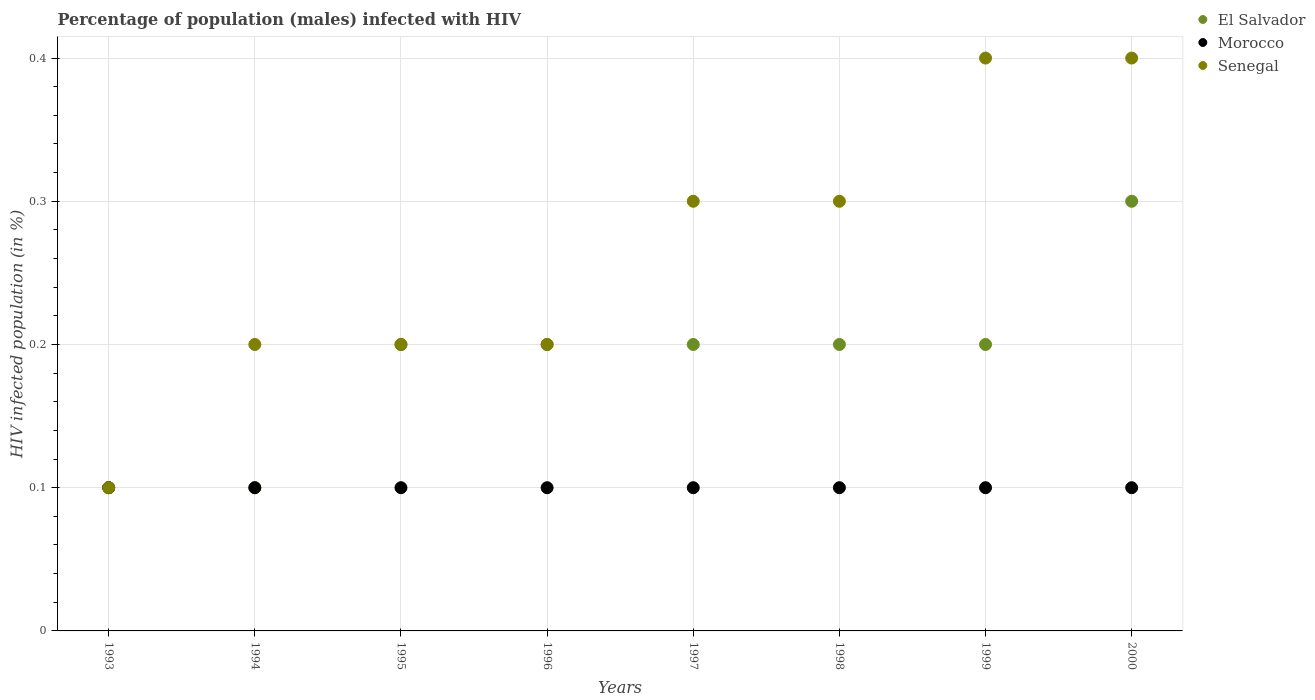Is the number of dotlines equal to the number of legend labels?
Your response must be concise. Yes. Across all years, what is the minimum percentage of HIV infected male population in Senegal?
Your answer should be very brief. 0.1. In which year was the percentage of HIV infected male population in Senegal maximum?
Your answer should be compact. 1999. What is the total percentage of HIV infected male population in Senegal in the graph?
Offer a terse response. 2.1. What is the difference between the percentage of HIV infected male population in Senegal in 1998 and the percentage of HIV infected male population in El Salvador in 1994?
Your answer should be very brief. 0.2. What is the average percentage of HIV infected male population in El Salvador per year?
Give a very brief answer. 0.19. In the year 1997, what is the difference between the percentage of HIV infected male population in Senegal and percentage of HIV infected male population in El Salvador?
Provide a succinct answer. 0.1. What is the ratio of the percentage of HIV infected male population in Senegal in 1995 to that in 1998?
Your answer should be very brief. 0.67. Is the percentage of HIV infected male population in Senegal in 1993 less than that in 1995?
Provide a short and direct response. Yes. Is the difference between the percentage of HIV infected male population in Senegal in 1996 and 1997 greater than the difference between the percentage of HIV infected male population in El Salvador in 1996 and 1997?
Keep it short and to the point. No. What is the difference between the highest and the second highest percentage of HIV infected male population in Senegal?
Your answer should be compact. 0. What is the difference between the highest and the lowest percentage of HIV infected male population in Senegal?
Your answer should be compact. 0.3. Is the sum of the percentage of HIV infected male population in Senegal in 1995 and 1999 greater than the maximum percentage of HIV infected male population in Morocco across all years?
Your answer should be very brief. Yes. Is the percentage of HIV infected male population in El Salvador strictly greater than the percentage of HIV infected male population in Morocco over the years?
Make the answer very short. No. How many dotlines are there?
Your response must be concise. 3. Are the values on the major ticks of Y-axis written in scientific E-notation?
Your answer should be compact. No. Where does the legend appear in the graph?
Keep it short and to the point. Top right. How many legend labels are there?
Give a very brief answer. 3. How are the legend labels stacked?
Your answer should be compact. Vertical. What is the title of the graph?
Your answer should be very brief. Percentage of population (males) infected with HIV. What is the label or title of the X-axis?
Provide a short and direct response. Years. What is the label or title of the Y-axis?
Your answer should be compact. HIV infected population (in %). What is the HIV infected population (in %) of El Salvador in 1993?
Offer a terse response. 0.1. What is the HIV infected population (in %) of Morocco in 1994?
Provide a succinct answer. 0.1. What is the HIV infected population (in %) in El Salvador in 1996?
Your response must be concise. 0.2. What is the HIV infected population (in %) of Morocco in 1996?
Keep it short and to the point. 0.1. What is the HIV infected population (in %) of El Salvador in 1997?
Provide a succinct answer. 0.2. What is the HIV infected population (in %) in Senegal in 1997?
Give a very brief answer. 0.3. What is the HIV infected population (in %) in Morocco in 1998?
Make the answer very short. 0.1. What is the HIV infected population (in %) in Senegal in 1998?
Offer a very short reply. 0.3. What is the HIV infected population (in %) in Senegal in 1999?
Keep it short and to the point. 0.4. What is the HIV infected population (in %) in El Salvador in 2000?
Offer a very short reply. 0.3. What is the HIV infected population (in %) of Morocco in 2000?
Make the answer very short. 0.1. What is the HIV infected population (in %) in Senegal in 2000?
Give a very brief answer. 0.4. Across all years, what is the maximum HIV infected population (in %) in El Salvador?
Your answer should be very brief. 0.3. Across all years, what is the minimum HIV infected population (in %) of Senegal?
Your answer should be compact. 0.1. What is the total HIV infected population (in %) of El Salvador in the graph?
Keep it short and to the point. 1.5. What is the total HIV infected population (in %) of Morocco in the graph?
Offer a very short reply. 0.8. What is the difference between the HIV infected population (in %) in Morocco in 1993 and that in 1994?
Keep it short and to the point. 0. What is the difference between the HIV infected population (in %) in El Salvador in 1993 and that in 1995?
Offer a terse response. -0.1. What is the difference between the HIV infected population (in %) in Senegal in 1993 and that in 1995?
Provide a short and direct response. -0.1. What is the difference between the HIV infected population (in %) in El Salvador in 1993 and that in 1997?
Offer a very short reply. -0.1. What is the difference between the HIV infected population (in %) in El Salvador in 1993 and that in 1998?
Ensure brevity in your answer.  -0.1. What is the difference between the HIV infected population (in %) in Morocco in 1993 and that in 1998?
Your response must be concise. 0. What is the difference between the HIV infected population (in %) in El Salvador in 1993 and that in 1999?
Your response must be concise. -0.1. What is the difference between the HIV infected population (in %) of Senegal in 1993 and that in 1999?
Your answer should be very brief. -0.3. What is the difference between the HIV infected population (in %) of El Salvador in 1993 and that in 2000?
Give a very brief answer. -0.2. What is the difference between the HIV infected population (in %) in Morocco in 1993 and that in 2000?
Offer a terse response. 0. What is the difference between the HIV infected population (in %) of Senegal in 1993 and that in 2000?
Your response must be concise. -0.3. What is the difference between the HIV infected population (in %) in Morocco in 1994 and that in 1995?
Your response must be concise. 0. What is the difference between the HIV infected population (in %) of Senegal in 1994 and that in 1995?
Make the answer very short. 0. What is the difference between the HIV infected population (in %) of El Salvador in 1994 and that in 1996?
Your answer should be compact. -0.1. What is the difference between the HIV infected population (in %) of Morocco in 1994 and that in 1996?
Your answer should be compact. 0. What is the difference between the HIV infected population (in %) of Senegal in 1994 and that in 1996?
Keep it short and to the point. 0. What is the difference between the HIV infected population (in %) in El Salvador in 1994 and that in 1997?
Keep it short and to the point. -0.1. What is the difference between the HIV infected population (in %) of Morocco in 1994 and that in 1998?
Give a very brief answer. 0. What is the difference between the HIV infected population (in %) of Senegal in 1994 and that in 1998?
Your answer should be very brief. -0.1. What is the difference between the HIV infected population (in %) in El Salvador in 1994 and that in 1999?
Keep it short and to the point. -0.1. What is the difference between the HIV infected population (in %) in El Salvador in 1994 and that in 2000?
Offer a very short reply. -0.2. What is the difference between the HIV infected population (in %) of Senegal in 1995 and that in 1996?
Give a very brief answer. 0. What is the difference between the HIV infected population (in %) of El Salvador in 1995 and that in 1997?
Your answer should be very brief. 0. What is the difference between the HIV infected population (in %) of El Salvador in 1995 and that in 1998?
Your answer should be very brief. 0. What is the difference between the HIV infected population (in %) of Morocco in 1995 and that in 1998?
Your answer should be very brief. 0. What is the difference between the HIV infected population (in %) in El Salvador in 1995 and that in 1999?
Offer a very short reply. 0. What is the difference between the HIV infected population (in %) of Senegal in 1995 and that in 1999?
Offer a terse response. -0.2. What is the difference between the HIV infected population (in %) in El Salvador in 1995 and that in 2000?
Your response must be concise. -0.1. What is the difference between the HIV infected population (in %) in Senegal in 1995 and that in 2000?
Provide a succinct answer. -0.2. What is the difference between the HIV infected population (in %) of Morocco in 1996 and that in 1997?
Provide a succinct answer. 0. What is the difference between the HIV infected population (in %) in Morocco in 1996 and that in 1998?
Your answer should be very brief. 0. What is the difference between the HIV infected population (in %) in Senegal in 1996 and that in 1998?
Offer a terse response. -0.1. What is the difference between the HIV infected population (in %) in El Salvador in 1996 and that in 1999?
Your answer should be compact. 0. What is the difference between the HIV infected population (in %) in Morocco in 1996 and that in 2000?
Make the answer very short. 0. What is the difference between the HIV infected population (in %) of El Salvador in 1997 and that in 1998?
Provide a short and direct response. 0. What is the difference between the HIV infected population (in %) of Senegal in 1997 and that in 1998?
Give a very brief answer. 0. What is the difference between the HIV infected population (in %) of Morocco in 1997 and that in 1999?
Your answer should be very brief. 0. What is the difference between the HIV infected population (in %) in Senegal in 1997 and that in 1999?
Offer a very short reply. -0.1. What is the difference between the HIV infected population (in %) of Morocco in 1998 and that in 1999?
Keep it short and to the point. 0. What is the difference between the HIV infected population (in %) of Senegal in 1998 and that in 1999?
Your answer should be compact. -0.1. What is the difference between the HIV infected population (in %) of El Salvador in 1998 and that in 2000?
Provide a short and direct response. -0.1. What is the difference between the HIV infected population (in %) in Morocco in 1998 and that in 2000?
Provide a succinct answer. 0. What is the difference between the HIV infected population (in %) in Morocco in 1999 and that in 2000?
Offer a terse response. 0. What is the difference between the HIV infected population (in %) in El Salvador in 1993 and the HIV infected population (in %) in Morocco in 1994?
Make the answer very short. 0. What is the difference between the HIV infected population (in %) in El Salvador in 1993 and the HIV infected population (in %) in Senegal in 1994?
Offer a very short reply. -0.1. What is the difference between the HIV infected population (in %) of El Salvador in 1993 and the HIV infected population (in %) of Senegal in 1995?
Your response must be concise. -0.1. What is the difference between the HIV infected population (in %) of Morocco in 1993 and the HIV infected population (in %) of Senegal in 1995?
Provide a short and direct response. -0.1. What is the difference between the HIV infected population (in %) of El Salvador in 1993 and the HIV infected population (in %) of Morocco in 1997?
Your answer should be very brief. 0. What is the difference between the HIV infected population (in %) of Morocco in 1993 and the HIV infected population (in %) of Senegal in 1997?
Your answer should be compact. -0.2. What is the difference between the HIV infected population (in %) in El Salvador in 1993 and the HIV infected population (in %) in Senegal in 1998?
Your answer should be compact. -0.2. What is the difference between the HIV infected population (in %) in Morocco in 1993 and the HIV infected population (in %) in Senegal in 1998?
Offer a very short reply. -0.2. What is the difference between the HIV infected population (in %) of El Salvador in 1994 and the HIV infected population (in %) of Senegal in 1995?
Keep it short and to the point. -0.1. What is the difference between the HIV infected population (in %) in Morocco in 1994 and the HIV infected population (in %) in Senegal in 1995?
Make the answer very short. -0.1. What is the difference between the HIV infected population (in %) in El Salvador in 1994 and the HIV infected population (in %) in Morocco in 1996?
Your answer should be very brief. 0. What is the difference between the HIV infected population (in %) in Morocco in 1994 and the HIV infected population (in %) in Senegal in 1996?
Your answer should be compact. -0.1. What is the difference between the HIV infected population (in %) of El Salvador in 1994 and the HIV infected population (in %) of Morocco in 1997?
Provide a succinct answer. 0. What is the difference between the HIV infected population (in %) in El Salvador in 1994 and the HIV infected population (in %) in Senegal in 1997?
Your answer should be compact. -0.2. What is the difference between the HIV infected population (in %) in Morocco in 1994 and the HIV infected population (in %) in Senegal in 1998?
Offer a terse response. -0.2. What is the difference between the HIV infected population (in %) in El Salvador in 1994 and the HIV infected population (in %) in Senegal in 1999?
Your response must be concise. -0.3. What is the difference between the HIV infected population (in %) in Morocco in 1994 and the HIV infected population (in %) in Senegal in 1999?
Provide a succinct answer. -0.3. What is the difference between the HIV infected population (in %) in El Salvador in 1994 and the HIV infected population (in %) in Morocco in 2000?
Your answer should be compact. 0. What is the difference between the HIV infected population (in %) of Morocco in 1995 and the HIV infected population (in %) of Senegal in 1996?
Keep it short and to the point. -0.1. What is the difference between the HIV infected population (in %) in El Salvador in 1995 and the HIV infected population (in %) in Morocco in 1997?
Your answer should be compact. 0.1. What is the difference between the HIV infected population (in %) of El Salvador in 1995 and the HIV infected population (in %) of Morocco in 1998?
Your response must be concise. 0.1. What is the difference between the HIV infected population (in %) in El Salvador in 1995 and the HIV infected population (in %) in Senegal in 1998?
Provide a short and direct response. -0.1. What is the difference between the HIV infected population (in %) in El Salvador in 1995 and the HIV infected population (in %) in Morocco in 1999?
Offer a terse response. 0.1. What is the difference between the HIV infected population (in %) of El Salvador in 1995 and the HIV infected population (in %) of Senegal in 1999?
Provide a succinct answer. -0.2. What is the difference between the HIV infected population (in %) in El Salvador in 1995 and the HIV infected population (in %) in Morocco in 2000?
Keep it short and to the point. 0.1. What is the difference between the HIV infected population (in %) in El Salvador in 1995 and the HIV infected population (in %) in Senegal in 2000?
Offer a terse response. -0.2. What is the difference between the HIV infected population (in %) of Morocco in 1995 and the HIV infected population (in %) of Senegal in 2000?
Offer a very short reply. -0.3. What is the difference between the HIV infected population (in %) of El Salvador in 1996 and the HIV infected population (in %) of Morocco in 1997?
Offer a terse response. 0.1. What is the difference between the HIV infected population (in %) of El Salvador in 1996 and the HIV infected population (in %) of Senegal in 1997?
Give a very brief answer. -0.1. What is the difference between the HIV infected population (in %) in Morocco in 1996 and the HIV infected population (in %) in Senegal in 1997?
Your answer should be compact. -0.2. What is the difference between the HIV infected population (in %) in El Salvador in 1996 and the HIV infected population (in %) in Morocco in 1998?
Your answer should be compact. 0.1. What is the difference between the HIV infected population (in %) of Morocco in 1996 and the HIV infected population (in %) of Senegal in 1998?
Keep it short and to the point. -0.2. What is the difference between the HIV infected population (in %) of El Salvador in 1996 and the HIV infected population (in %) of Morocco in 1999?
Ensure brevity in your answer.  0.1. What is the difference between the HIV infected population (in %) of Morocco in 1996 and the HIV infected population (in %) of Senegal in 2000?
Offer a very short reply. -0.3. What is the difference between the HIV infected population (in %) in El Salvador in 1997 and the HIV infected population (in %) in Morocco in 1998?
Your response must be concise. 0.1. What is the difference between the HIV infected population (in %) of El Salvador in 1997 and the HIV infected population (in %) of Senegal in 1998?
Keep it short and to the point. -0.1. What is the difference between the HIV infected population (in %) in Morocco in 1997 and the HIV infected population (in %) in Senegal in 1998?
Provide a short and direct response. -0.2. What is the difference between the HIV infected population (in %) of El Salvador in 1997 and the HIV infected population (in %) of Morocco in 1999?
Make the answer very short. 0.1. What is the difference between the HIV infected population (in %) of El Salvador in 1997 and the HIV infected population (in %) of Senegal in 1999?
Provide a succinct answer. -0.2. What is the difference between the HIV infected population (in %) of Morocco in 1997 and the HIV infected population (in %) of Senegal in 2000?
Your response must be concise. -0.3. What is the difference between the HIV infected population (in %) of El Salvador in 1998 and the HIV infected population (in %) of Morocco in 1999?
Your answer should be compact. 0.1. What is the difference between the HIV infected population (in %) in Morocco in 1998 and the HIV infected population (in %) in Senegal in 1999?
Offer a very short reply. -0.3. What is the difference between the HIV infected population (in %) of El Salvador in 1998 and the HIV infected population (in %) of Morocco in 2000?
Ensure brevity in your answer.  0.1. What is the difference between the HIV infected population (in %) in El Salvador in 1998 and the HIV infected population (in %) in Senegal in 2000?
Give a very brief answer. -0.2. What is the difference between the HIV infected population (in %) in Morocco in 1999 and the HIV infected population (in %) in Senegal in 2000?
Keep it short and to the point. -0.3. What is the average HIV infected population (in %) of El Salvador per year?
Make the answer very short. 0.19. What is the average HIV infected population (in %) in Senegal per year?
Your answer should be compact. 0.26. In the year 1993, what is the difference between the HIV infected population (in %) of El Salvador and HIV infected population (in %) of Senegal?
Your response must be concise. 0. In the year 1994, what is the difference between the HIV infected population (in %) in El Salvador and HIV infected population (in %) in Morocco?
Make the answer very short. 0. In the year 1994, what is the difference between the HIV infected population (in %) of Morocco and HIV infected population (in %) of Senegal?
Offer a terse response. -0.1. In the year 1995, what is the difference between the HIV infected population (in %) of Morocco and HIV infected population (in %) of Senegal?
Offer a terse response. -0.1. In the year 1996, what is the difference between the HIV infected population (in %) in El Salvador and HIV infected population (in %) in Morocco?
Provide a succinct answer. 0.1. In the year 1996, what is the difference between the HIV infected population (in %) in El Salvador and HIV infected population (in %) in Senegal?
Make the answer very short. 0. In the year 1996, what is the difference between the HIV infected population (in %) of Morocco and HIV infected population (in %) of Senegal?
Your response must be concise. -0.1. In the year 1997, what is the difference between the HIV infected population (in %) of El Salvador and HIV infected population (in %) of Morocco?
Keep it short and to the point. 0.1. In the year 1997, what is the difference between the HIV infected population (in %) of El Salvador and HIV infected population (in %) of Senegal?
Keep it short and to the point. -0.1. In the year 1998, what is the difference between the HIV infected population (in %) of El Salvador and HIV infected population (in %) of Morocco?
Your response must be concise. 0.1. In the year 1998, what is the difference between the HIV infected population (in %) of Morocco and HIV infected population (in %) of Senegal?
Provide a short and direct response. -0.2. In the year 1999, what is the difference between the HIV infected population (in %) in Morocco and HIV infected population (in %) in Senegal?
Provide a short and direct response. -0.3. In the year 2000, what is the difference between the HIV infected population (in %) in El Salvador and HIV infected population (in %) in Senegal?
Your response must be concise. -0.1. In the year 2000, what is the difference between the HIV infected population (in %) of Morocco and HIV infected population (in %) of Senegal?
Your response must be concise. -0.3. What is the ratio of the HIV infected population (in %) in Morocco in 1993 to that in 1995?
Your answer should be very brief. 1. What is the ratio of the HIV infected population (in %) of Senegal in 1993 to that in 1995?
Provide a short and direct response. 0.5. What is the ratio of the HIV infected population (in %) of Senegal in 1993 to that in 1996?
Provide a succinct answer. 0.5. What is the ratio of the HIV infected population (in %) in Morocco in 1993 to that in 1997?
Make the answer very short. 1. What is the ratio of the HIV infected population (in %) of El Salvador in 1993 to that in 1998?
Provide a succinct answer. 0.5. What is the ratio of the HIV infected population (in %) in Senegal in 1993 to that in 1998?
Provide a short and direct response. 0.33. What is the ratio of the HIV infected population (in %) in El Salvador in 1993 to that in 1999?
Your answer should be compact. 0.5. What is the ratio of the HIV infected population (in %) of Morocco in 1993 to that in 2000?
Make the answer very short. 1. What is the ratio of the HIV infected population (in %) in Senegal in 1993 to that in 2000?
Your response must be concise. 0.25. What is the ratio of the HIV infected population (in %) of Senegal in 1994 to that in 1995?
Your answer should be very brief. 1. What is the ratio of the HIV infected population (in %) in El Salvador in 1994 to that in 1996?
Offer a very short reply. 0.5. What is the ratio of the HIV infected population (in %) of Senegal in 1994 to that in 1996?
Offer a very short reply. 1. What is the ratio of the HIV infected population (in %) in Senegal in 1994 to that in 1997?
Provide a succinct answer. 0.67. What is the ratio of the HIV infected population (in %) in Morocco in 1994 to that in 1998?
Provide a succinct answer. 1. What is the ratio of the HIV infected population (in %) of El Salvador in 1994 to that in 1999?
Give a very brief answer. 0.5. What is the ratio of the HIV infected population (in %) in Senegal in 1994 to that in 1999?
Keep it short and to the point. 0.5. What is the ratio of the HIV infected population (in %) of El Salvador in 1994 to that in 2000?
Offer a very short reply. 0.33. What is the ratio of the HIV infected population (in %) of Morocco in 1995 to that in 1996?
Offer a very short reply. 1. What is the ratio of the HIV infected population (in %) of El Salvador in 1995 to that in 1997?
Offer a very short reply. 1. What is the ratio of the HIV infected population (in %) of Morocco in 1995 to that in 1997?
Make the answer very short. 1. What is the ratio of the HIV infected population (in %) of Senegal in 1995 to that in 1997?
Provide a short and direct response. 0.67. What is the ratio of the HIV infected population (in %) in El Salvador in 1995 to that in 1999?
Offer a very short reply. 1. What is the ratio of the HIV infected population (in %) of Morocco in 1995 to that in 1999?
Your answer should be compact. 1. What is the ratio of the HIV infected population (in %) of Morocco in 1995 to that in 2000?
Provide a short and direct response. 1. What is the ratio of the HIV infected population (in %) of El Salvador in 1996 to that in 1997?
Your answer should be very brief. 1. What is the ratio of the HIV infected population (in %) in Morocco in 1996 to that in 1997?
Give a very brief answer. 1. What is the ratio of the HIV infected population (in %) of Senegal in 1996 to that in 1997?
Ensure brevity in your answer.  0.67. What is the ratio of the HIV infected population (in %) of Morocco in 1996 to that in 1998?
Ensure brevity in your answer.  1. What is the ratio of the HIV infected population (in %) in Senegal in 1996 to that in 1998?
Give a very brief answer. 0.67. What is the ratio of the HIV infected population (in %) of Morocco in 1996 to that in 1999?
Offer a very short reply. 1. What is the ratio of the HIV infected population (in %) of Senegal in 1996 to that in 1999?
Keep it short and to the point. 0.5. What is the ratio of the HIV infected population (in %) of Senegal in 1996 to that in 2000?
Ensure brevity in your answer.  0.5. What is the ratio of the HIV infected population (in %) in Morocco in 1997 to that in 1998?
Ensure brevity in your answer.  1. What is the ratio of the HIV infected population (in %) in El Salvador in 1997 to that in 1999?
Your answer should be very brief. 1. What is the ratio of the HIV infected population (in %) of Morocco in 1997 to that in 1999?
Provide a succinct answer. 1. What is the ratio of the HIV infected population (in %) of El Salvador in 1997 to that in 2000?
Offer a very short reply. 0.67. What is the ratio of the HIV infected population (in %) in Senegal in 1997 to that in 2000?
Your answer should be compact. 0.75. What is the ratio of the HIV infected population (in %) of El Salvador in 1998 to that in 1999?
Offer a terse response. 1. What is the ratio of the HIV infected population (in %) of Senegal in 1998 to that in 1999?
Keep it short and to the point. 0.75. What is the ratio of the HIV infected population (in %) of El Salvador in 1998 to that in 2000?
Provide a short and direct response. 0.67. What is the ratio of the HIV infected population (in %) in Senegal in 1998 to that in 2000?
Offer a very short reply. 0.75. What is the ratio of the HIV infected population (in %) in Morocco in 1999 to that in 2000?
Give a very brief answer. 1. What is the ratio of the HIV infected population (in %) in Senegal in 1999 to that in 2000?
Make the answer very short. 1. What is the difference between the highest and the lowest HIV infected population (in %) of El Salvador?
Your response must be concise. 0.2. What is the difference between the highest and the lowest HIV infected population (in %) of Senegal?
Your answer should be compact. 0.3. 